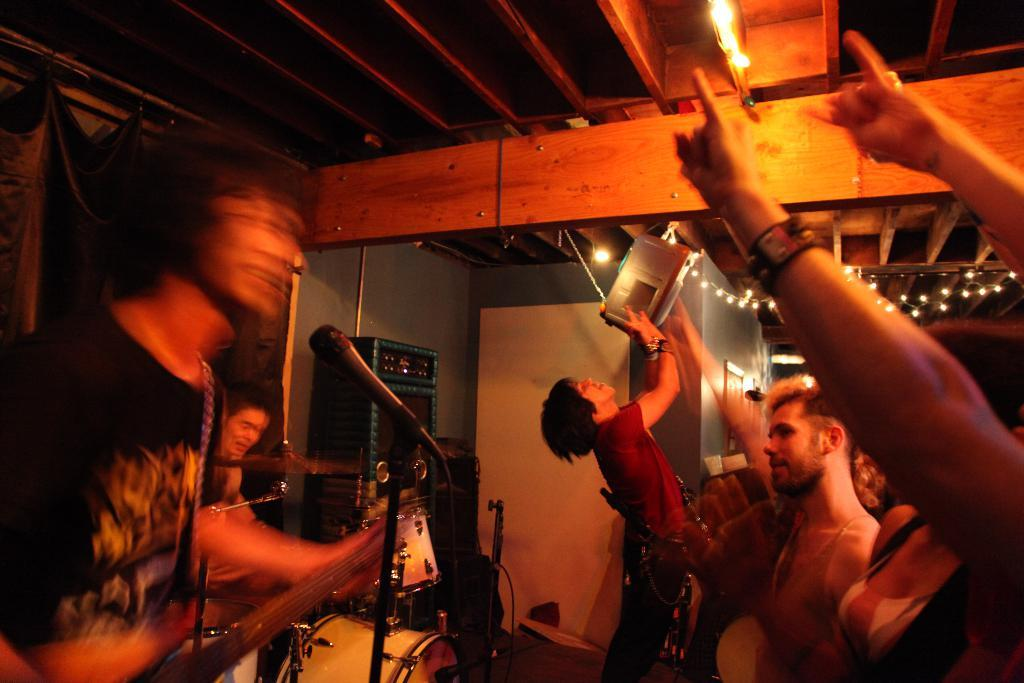How many people are in the image? There is a group of persons in the image. What is one person doing in the image? One person is playing the guitar. What object is present in the image that is used for amplifying sound? There is a microphone in the image. What instrument can be seen being played in the background of the image? A person is playing the drums in the background. Is there any smoke coming from the instruments in the image? There is no smoke visible in the image; the instruments are not shown producing any smoke. What type of animals can be seen in the zoo in the image? There is no zoo present in the image; it features a group of people playing musical instruments. 